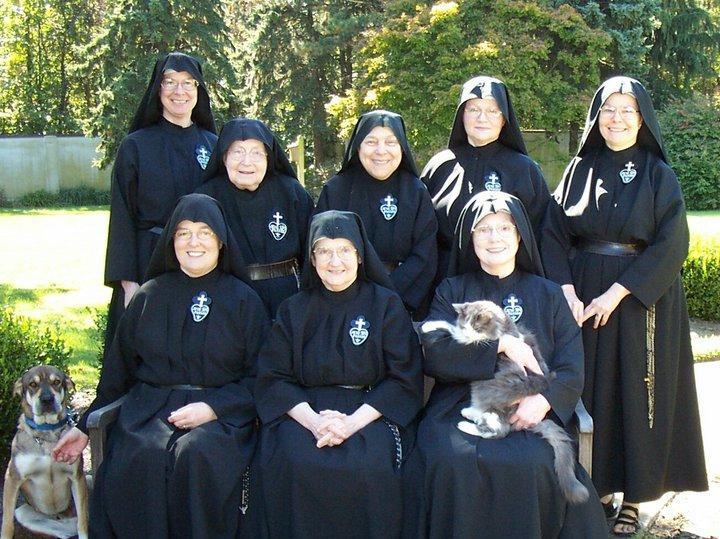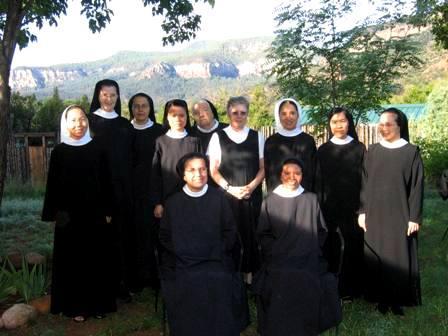The first image is the image on the left, the second image is the image on the right. For the images shown, is this caption "At least 10 nuns are posing as a group in one of the pictures." true? Answer yes or no. Yes. The first image is the image on the left, the second image is the image on the right. Assess this claim about the two images: "There are women and no men in the left image.". Correct or not? Answer yes or no. Yes. 